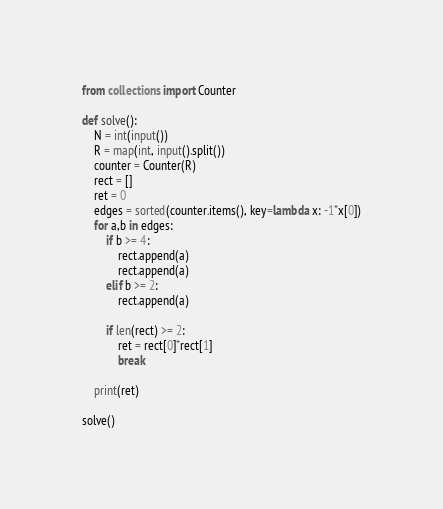Convert code to text. <code><loc_0><loc_0><loc_500><loc_500><_Python_>from collections import Counter

def solve():
    N = int(input())
    R = map(int, input().split())
    counter = Counter(R)
    rect = []
    ret = 0
    edges = sorted(counter.items(), key=lambda x: -1*x[0])
    for a,b in edges:
        if b >= 4:
            rect.append(a)
            rect.append(a)
        elif b >= 2:
            rect.append(a)
        
        if len(rect) >= 2: 
            ret = rect[0]*rect[1]
            break
            
    print(ret)
    
solve()</code> 